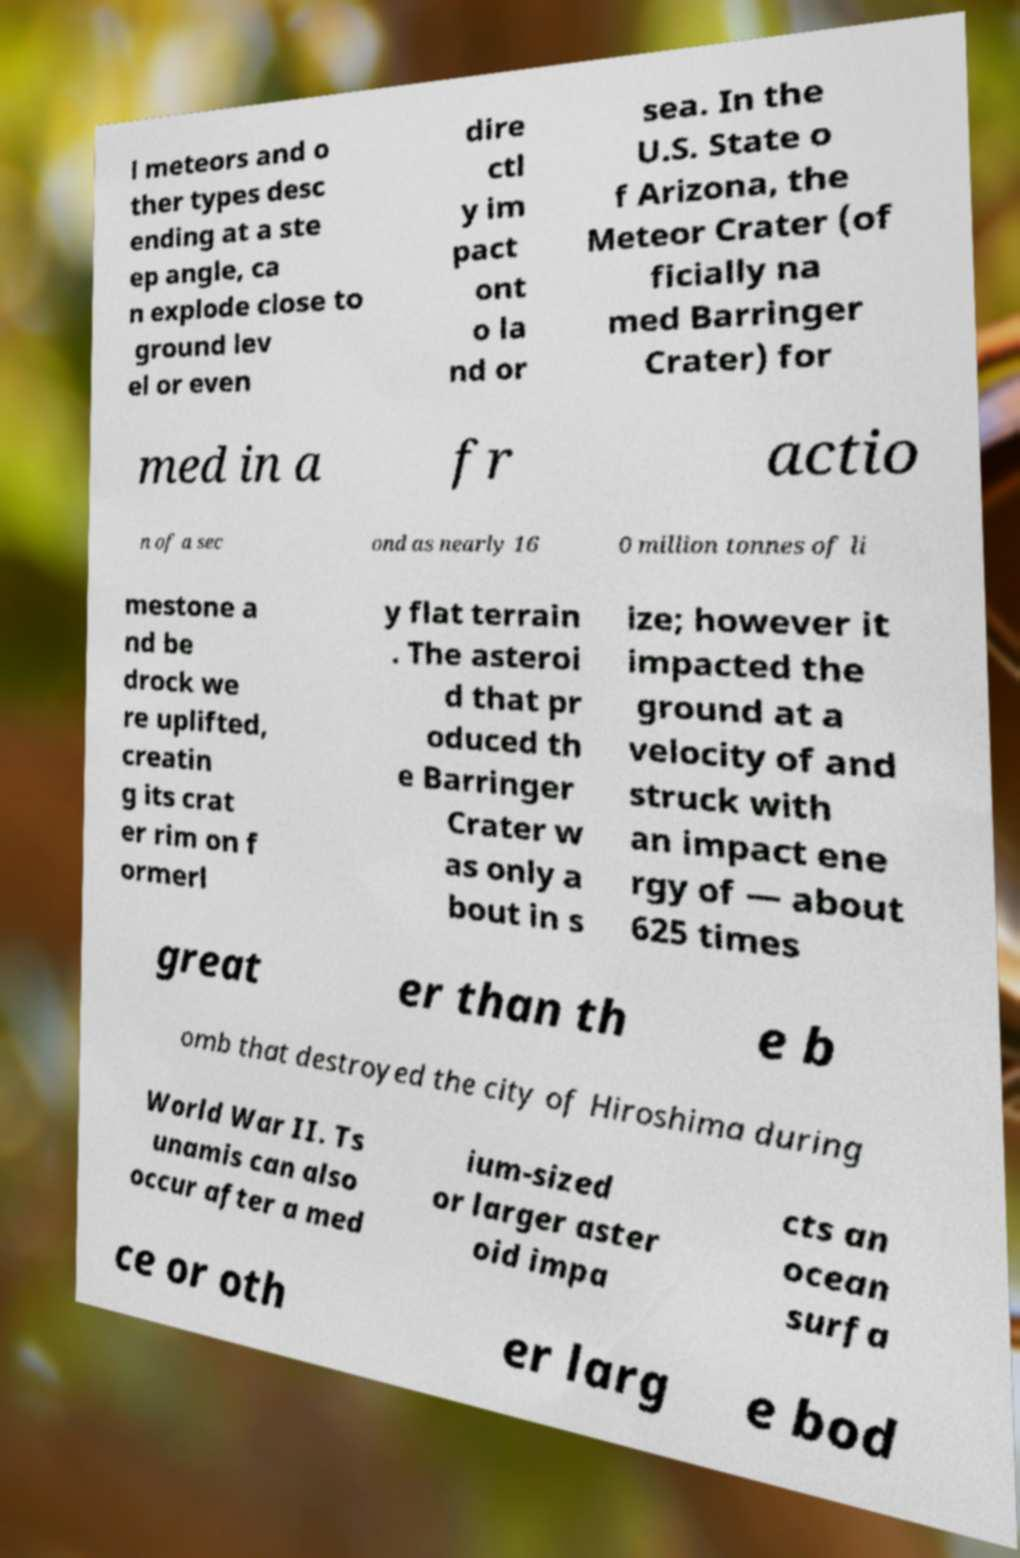Please read and relay the text visible in this image. What does it say? l meteors and o ther types desc ending at a ste ep angle, ca n explode close to ground lev el or even dire ctl y im pact ont o la nd or sea. In the U.S. State o f Arizona, the Meteor Crater (of ficially na med Barringer Crater) for med in a fr actio n of a sec ond as nearly 16 0 million tonnes of li mestone a nd be drock we re uplifted, creatin g its crat er rim on f ormerl y flat terrain . The asteroi d that pr oduced th e Barringer Crater w as only a bout in s ize; however it impacted the ground at a velocity of and struck with an impact ene rgy of — about 625 times great er than th e b omb that destroyed the city of Hiroshima during World War II. Ts unamis can also occur after a med ium-sized or larger aster oid impa cts an ocean surfa ce or oth er larg e bod 